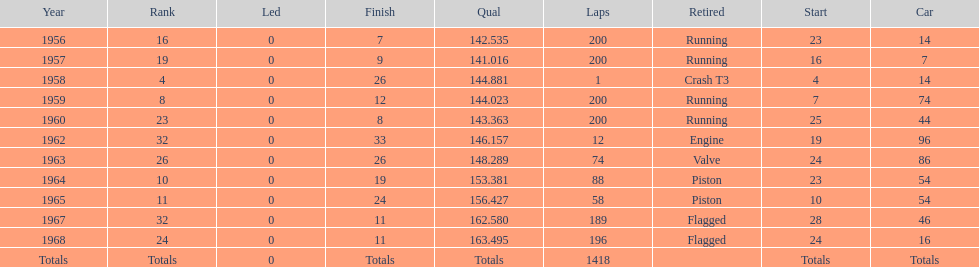Which year is the last qual on the chart 1968. 